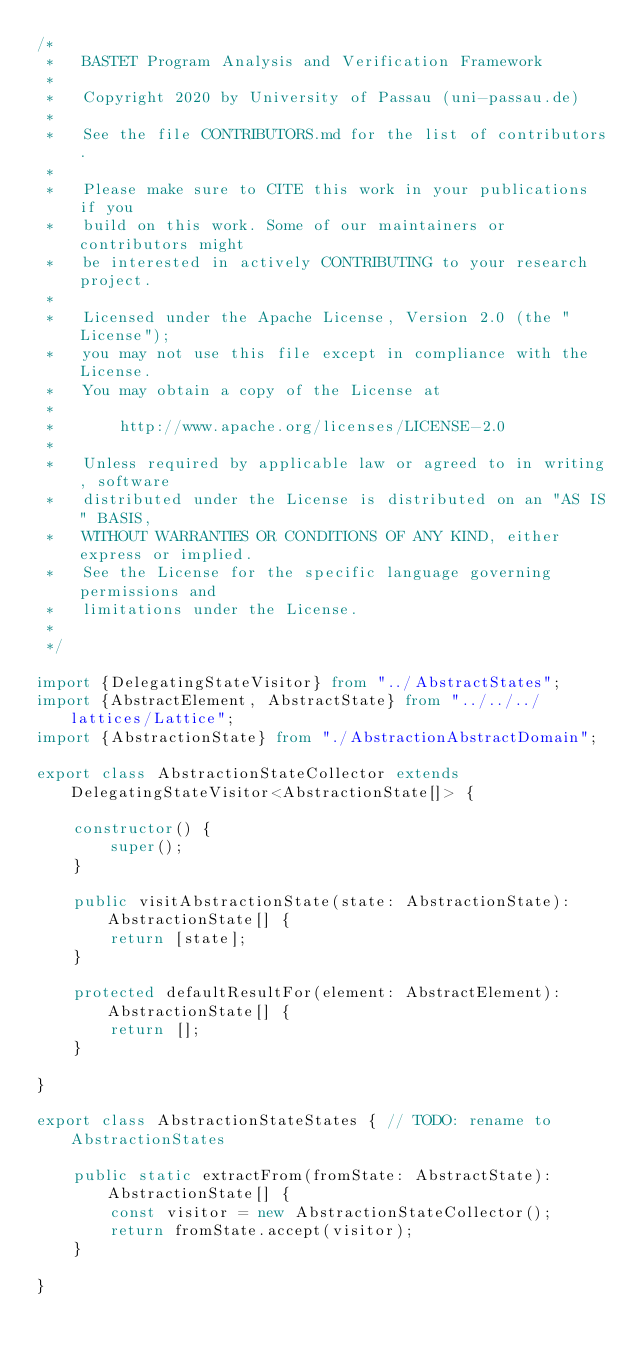Convert code to text. <code><loc_0><loc_0><loc_500><loc_500><_TypeScript_>/*
 *   BASTET Program Analysis and Verification Framework
 *
 *   Copyright 2020 by University of Passau (uni-passau.de)
 *
 *   See the file CONTRIBUTORS.md for the list of contributors.
 *
 *   Please make sure to CITE this work in your publications if you
 *   build on this work. Some of our maintainers or contributors might
 *   be interested in actively CONTRIBUTING to your research project.
 *
 *   Licensed under the Apache License, Version 2.0 (the "License");
 *   you may not use this file except in compliance with the License.
 *   You may obtain a copy of the License at
 *
 *       http://www.apache.org/licenses/LICENSE-2.0
 *
 *   Unless required by applicable law or agreed to in writing, software
 *   distributed under the License is distributed on an "AS IS" BASIS,
 *   WITHOUT WARRANTIES OR CONDITIONS OF ANY KIND, either express or implied.
 *   See the License for the specific language governing permissions and
 *   limitations under the License.
 *
 */

import {DelegatingStateVisitor} from "../AbstractStates";
import {AbstractElement, AbstractState} from "../../../lattices/Lattice";
import {AbstractionState} from "./AbstractionAbstractDomain";

export class AbstractionStateCollector extends DelegatingStateVisitor<AbstractionState[]> {

    constructor() {
        super();
    }

    public visitAbstractionState(state: AbstractionState): AbstractionState[] {
        return [state];
    }

    protected defaultResultFor(element: AbstractElement): AbstractionState[] {
        return [];
    }

}

export class AbstractionStateStates { // TODO: rename to AbstractionStates

    public static extractFrom(fromState: AbstractState): AbstractionState[] {
        const visitor = new AbstractionStateCollector();
        return fromState.accept(visitor);
    }

}</code> 